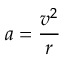Convert formula to latex. <formula><loc_0><loc_0><loc_500><loc_500>a = { \frac { v ^ { 2 } } { r } }</formula> 